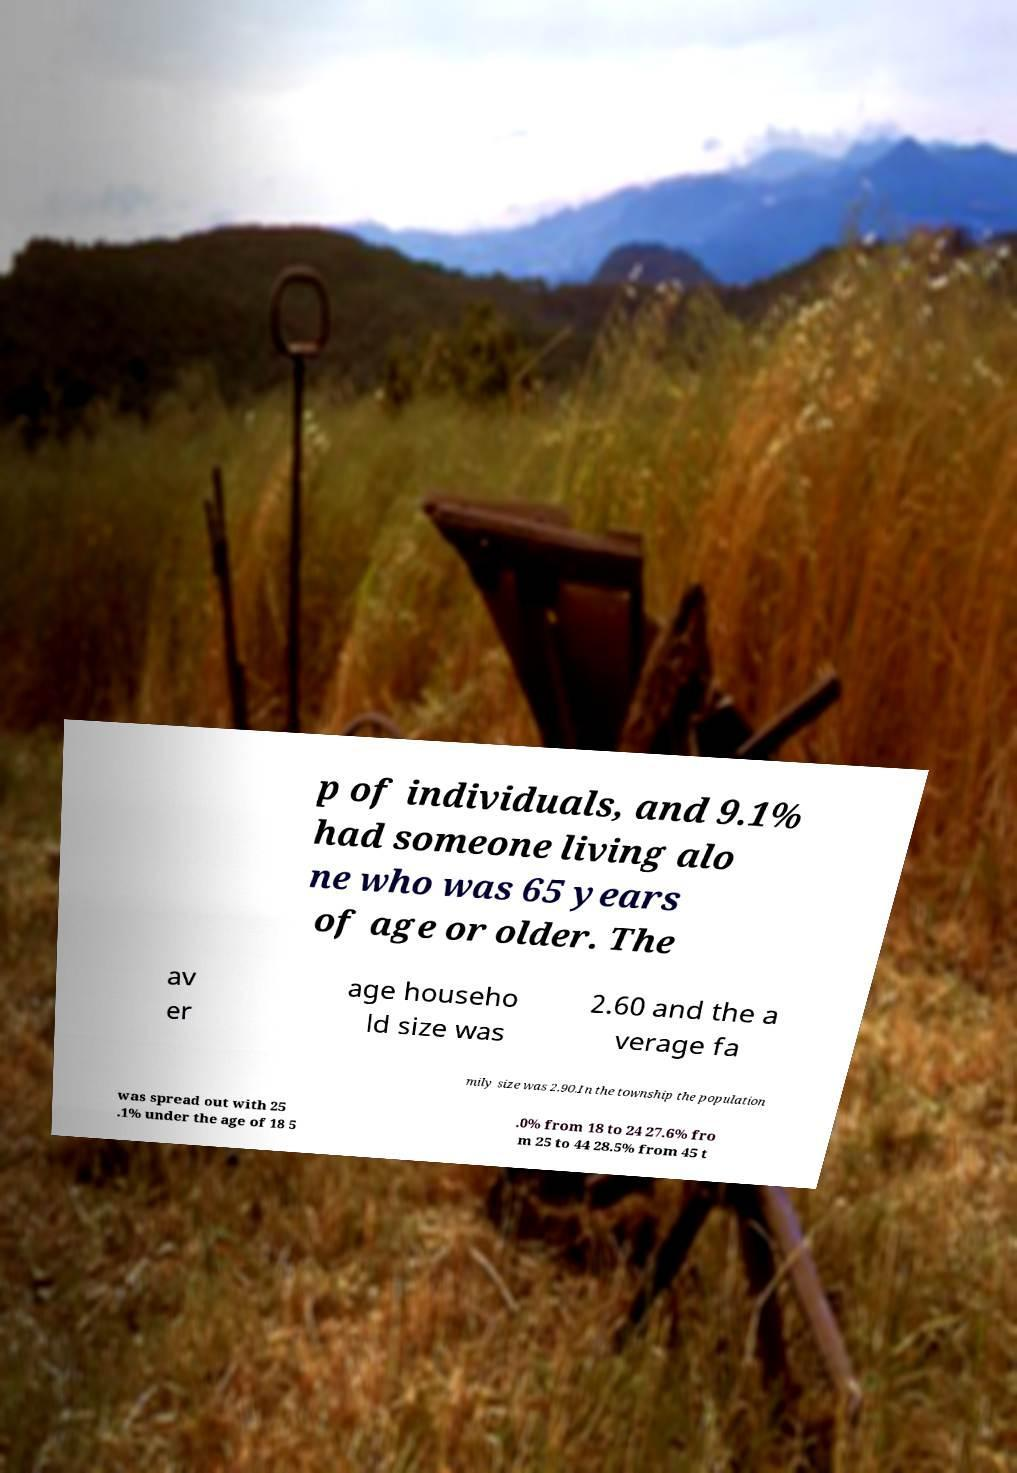Please read and relay the text visible in this image. What does it say? p of individuals, and 9.1% had someone living alo ne who was 65 years of age or older. The av er age househo ld size was 2.60 and the a verage fa mily size was 2.90.In the township the population was spread out with 25 .1% under the age of 18 5 .0% from 18 to 24 27.6% fro m 25 to 44 28.5% from 45 t 